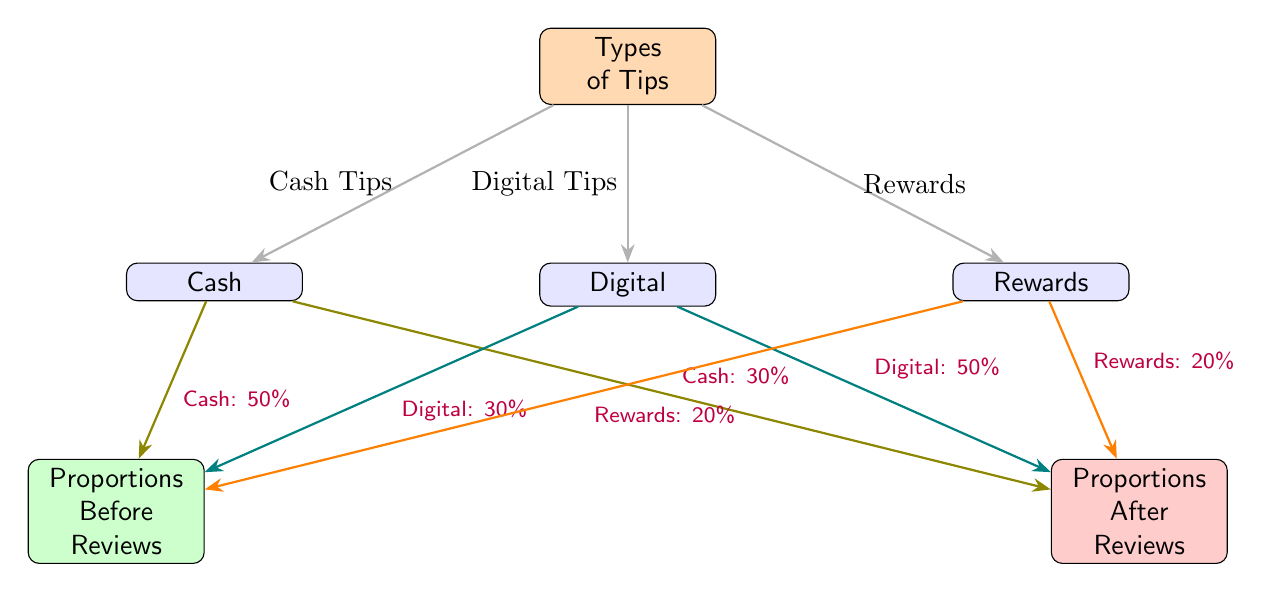What types of tips are categorized in the diagram? The diagram categorizes tips into three types: Cash, Digital, and Rewards. These are represented as distinct nodes originating from the central "Types of Tips" node.
Answer: Cash, Digital, Rewards What is the proportion of cash tips before reviews? To find the proportion of cash tips before reviews, we look at the arrow leading from the Cash node to the "Proportions Before Reviews" node, which states "Cash: 50%."
Answer: 50% What was the proportion of digital tips after reviews? The diagram indicates this by following the arrow from the Digital node to the "Proportions After Reviews" node where it states "Digital: 50%."
Answer: 50% How many tip categories are shown in the diagram? The diagram includes three tip categories: Cash, Digital, and Rewards. These can be counted as the nodes branching from the "Types of Tips" node.
Answer: 3 What was the same proportion of rewards tips before and after reviews? The rewards tips maintain the same proportion both before and after reviews; this is indicated by "Rewards: 20%" in both cases.
Answer: 20% Are there more digital tips before or after the reviews? To answer this, we compare the proportions: Digital tips were at "30%" before and "50%" after the reviews. Therefore, there are more digital tips after the reviews.
Answer: After Which tip category has the highest change in proportion after reviews? By comparing the changes in proportion: cash goes from "50%" to "30%" (a decrease), digital goes from "30%" to "50%" (an increase), and rewards stays at "20%." Thus, the digital tips have the highest increase.
Answer: Digital What color represents the proportions before reviews in the diagram? In the diagram, the proportions before reviews are represented by a green box, as shown through the corresponding node connected to each tip category.
Answer: Green What is the total percentage of tips after reviews? To determine the total percentage of tips after reviews, we summarize the proportions: Cash 30% + Digital 50% + Rewards 20% = 100%.
Answer: 100% 